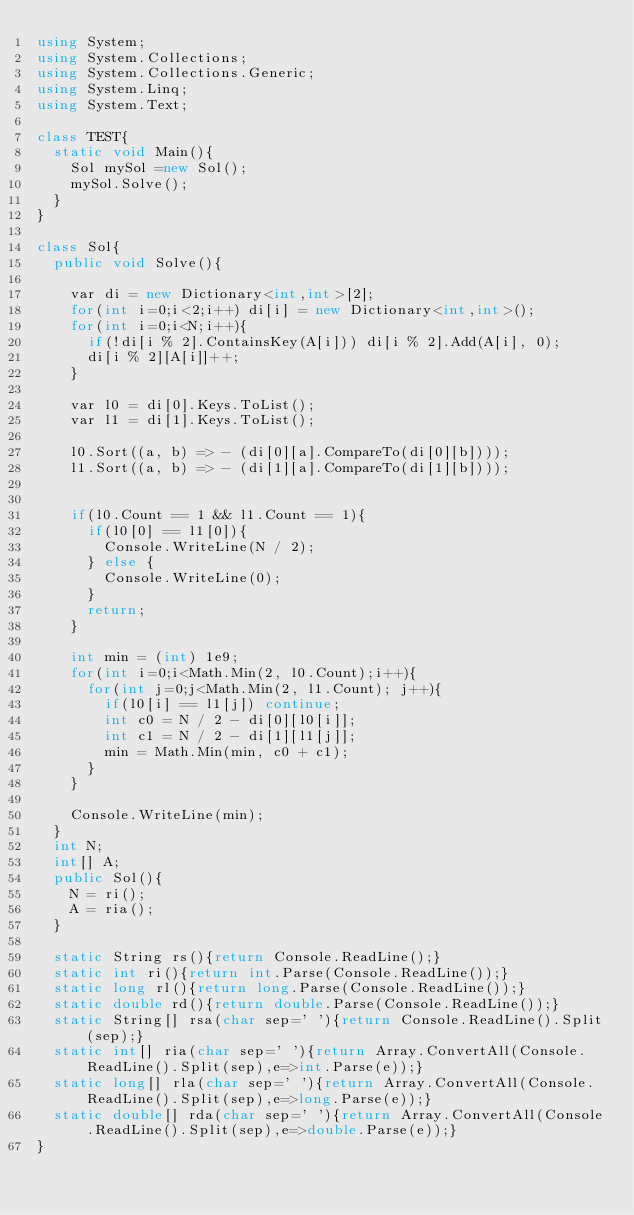Convert code to text. <code><loc_0><loc_0><loc_500><loc_500><_C#_>using System;
using System.Collections;
using System.Collections.Generic;
using System.Linq;
using System.Text;

class TEST{
	static void Main(){
		Sol mySol =new Sol();
		mySol.Solve();
	}
}

class Sol{
	public void Solve(){
		
		var di = new Dictionary<int,int>[2];
		for(int i=0;i<2;i++) di[i] = new Dictionary<int,int>();
		for(int i=0;i<N;i++){
			if(!di[i % 2].ContainsKey(A[i])) di[i % 2].Add(A[i], 0);
			di[i % 2][A[i]]++;
		}
		
		var l0 = di[0].Keys.ToList();
		var l1 = di[1].Keys.ToList();
		
		l0.Sort((a, b) => - (di[0][a].CompareTo(di[0][b])));
		l1.Sort((a, b) => - (di[1][a].CompareTo(di[1][b])));
		
		
		if(l0.Count == 1 && l1.Count == 1){
			if(l0[0] == l1[0]){
				Console.WriteLine(N / 2);
			} else {
				Console.WriteLine(0);
			}
			return;
		}
		
		int min = (int) 1e9;
		for(int i=0;i<Math.Min(2, l0.Count);i++){
			for(int j=0;j<Math.Min(2, l1.Count); j++){
				if(l0[i] == l1[j]) continue;
				int c0 = N / 2 - di[0][l0[i]];
				int c1 = N / 2 - di[1][l1[j]];
				min = Math.Min(min, c0 + c1);
			}
		}
		
		Console.WriteLine(min);
	}
	int N;
	int[] A;
	public Sol(){
		N = ri();
		A = ria();
	}

	static String rs(){return Console.ReadLine();}
	static int ri(){return int.Parse(Console.ReadLine());}
	static long rl(){return long.Parse(Console.ReadLine());}
	static double rd(){return double.Parse(Console.ReadLine());}
	static String[] rsa(char sep=' '){return Console.ReadLine().Split(sep);}
	static int[] ria(char sep=' '){return Array.ConvertAll(Console.ReadLine().Split(sep),e=>int.Parse(e));}
	static long[] rla(char sep=' '){return Array.ConvertAll(Console.ReadLine().Split(sep),e=>long.Parse(e));}
	static double[] rda(char sep=' '){return Array.ConvertAll(Console.ReadLine().Split(sep),e=>double.Parse(e));}
}
</code> 